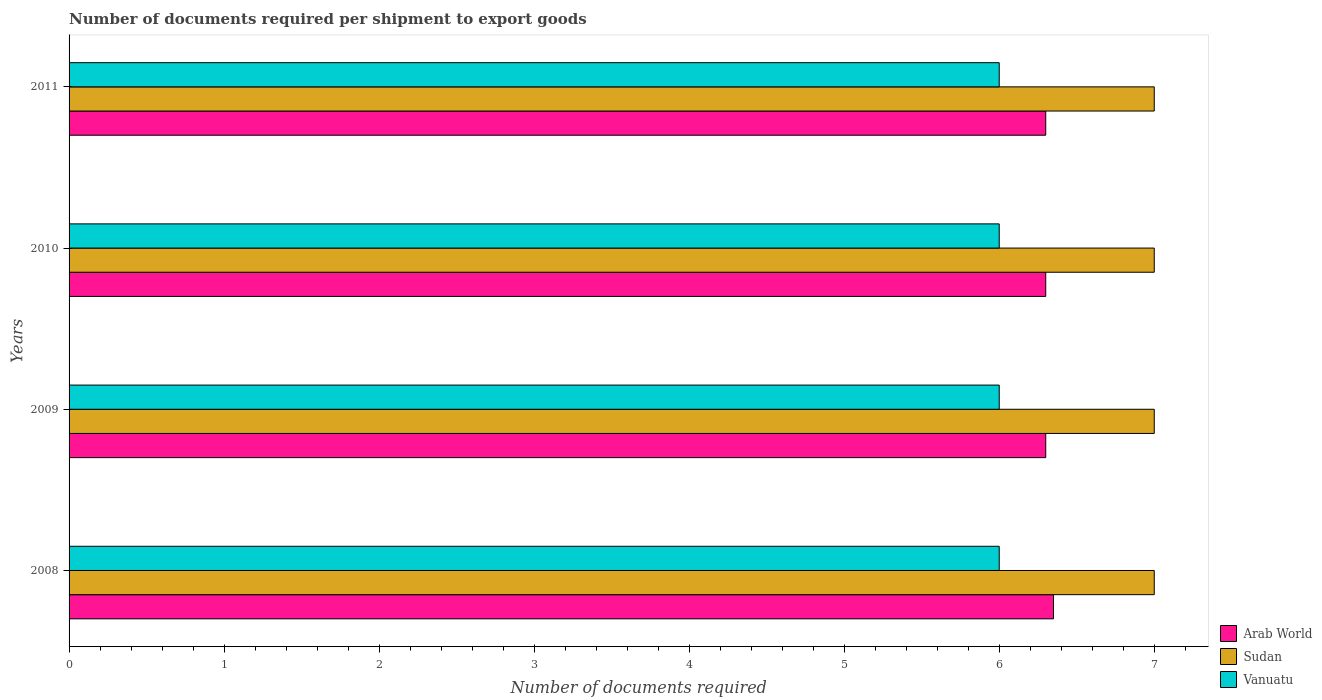How many bars are there on the 3rd tick from the bottom?
Offer a terse response. 3. What is the number of documents required per shipment to export goods in Arab World in 2011?
Ensure brevity in your answer.  6.3. Across all years, what is the maximum number of documents required per shipment to export goods in Sudan?
Offer a very short reply. 7. Across all years, what is the minimum number of documents required per shipment to export goods in Vanuatu?
Offer a very short reply. 6. In which year was the number of documents required per shipment to export goods in Vanuatu maximum?
Give a very brief answer. 2008. What is the total number of documents required per shipment to export goods in Arab World in the graph?
Provide a succinct answer. 25.25. What is the difference between the number of documents required per shipment to export goods in Vanuatu in 2008 and that in 2010?
Make the answer very short. 0. What is the difference between the number of documents required per shipment to export goods in Arab World in 2009 and the number of documents required per shipment to export goods in Vanuatu in 2011?
Give a very brief answer. 0.3. What is the average number of documents required per shipment to export goods in Arab World per year?
Make the answer very short. 6.31. In the year 2010, what is the difference between the number of documents required per shipment to export goods in Vanuatu and number of documents required per shipment to export goods in Sudan?
Provide a succinct answer. -1. What is the ratio of the number of documents required per shipment to export goods in Sudan in 2010 to that in 2011?
Offer a very short reply. 1. Is the difference between the number of documents required per shipment to export goods in Vanuatu in 2008 and 2009 greater than the difference between the number of documents required per shipment to export goods in Sudan in 2008 and 2009?
Provide a short and direct response. No. What is the difference between the highest and the second highest number of documents required per shipment to export goods in Vanuatu?
Your response must be concise. 0. What is the difference between the highest and the lowest number of documents required per shipment to export goods in Arab World?
Provide a short and direct response. 0.05. Is the sum of the number of documents required per shipment to export goods in Arab World in 2008 and 2011 greater than the maximum number of documents required per shipment to export goods in Vanuatu across all years?
Make the answer very short. Yes. What does the 3rd bar from the top in 2011 represents?
Offer a very short reply. Arab World. What does the 2nd bar from the bottom in 2010 represents?
Provide a succinct answer. Sudan. Is it the case that in every year, the sum of the number of documents required per shipment to export goods in Vanuatu and number of documents required per shipment to export goods in Sudan is greater than the number of documents required per shipment to export goods in Arab World?
Provide a short and direct response. Yes. How many bars are there?
Give a very brief answer. 12. Are all the bars in the graph horizontal?
Provide a short and direct response. Yes. What is the difference between two consecutive major ticks on the X-axis?
Offer a terse response. 1. Does the graph contain grids?
Give a very brief answer. No. What is the title of the graph?
Provide a short and direct response. Number of documents required per shipment to export goods. What is the label or title of the X-axis?
Offer a terse response. Number of documents required. What is the Number of documents required in Arab World in 2008?
Make the answer very short. 6.35. What is the Number of documents required in Sudan in 2008?
Ensure brevity in your answer.  7. What is the Number of documents required in Arab World in 2009?
Provide a succinct answer. 6.3. What is the Number of documents required in Sudan in 2009?
Offer a terse response. 7. What is the Number of documents required in Vanuatu in 2009?
Offer a terse response. 6. What is the Number of documents required of Arab World in 2010?
Provide a succinct answer. 6.3. Across all years, what is the maximum Number of documents required in Arab World?
Your answer should be very brief. 6.35. Across all years, what is the maximum Number of documents required of Vanuatu?
Keep it short and to the point. 6. Across all years, what is the minimum Number of documents required in Arab World?
Make the answer very short. 6.3. Across all years, what is the minimum Number of documents required in Sudan?
Provide a succinct answer. 7. What is the total Number of documents required in Arab World in the graph?
Make the answer very short. 25.25. What is the total Number of documents required of Sudan in the graph?
Ensure brevity in your answer.  28. What is the difference between the Number of documents required of Arab World in 2008 and that in 2009?
Your answer should be very brief. 0.05. What is the difference between the Number of documents required of Sudan in 2008 and that in 2009?
Offer a terse response. 0. What is the difference between the Number of documents required of Vanuatu in 2009 and that in 2010?
Offer a very short reply. 0. What is the difference between the Number of documents required of Arab World in 2009 and that in 2011?
Keep it short and to the point. 0. What is the difference between the Number of documents required in Sudan in 2009 and that in 2011?
Provide a short and direct response. 0. What is the difference between the Number of documents required in Vanuatu in 2009 and that in 2011?
Offer a very short reply. 0. What is the difference between the Number of documents required in Arab World in 2010 and that in 2011?
Ensure brevity in your answer.  0. What is the difference between the Number of documents required in Arab World in 2008 and the Number of documents required in Sudan in 2009?
Your answer should be compact. -0.65. What is the difference between the Number of documents required of Sudan in 2008 and the Number of documents required of Vanuatu in 2009?
Keep it short and to the point. 1. What is the difference between the Number of documents required of Arab World in 2008 and the Number of documents required of Sudan in 2010?
Offer a very short reply. -0.65. What is the difference between the Number of documents required in Arab World in 2008 and the Number of documents required in Sudan in 2011?
Your answer should be very brief. -0.65. What is the difference between the Number of documents required of Arab World in 2008 and the Number of documents required of Vanuatu in 2011?
Provide a short and direct response. 0.35. What is the difference between the Number of documents required in Sudan in 2008 and the Number of documents required in Vanuatu in 2011?
Ensure brevity in your answer.  1. What is the difference between the Number of documents required in Arab World in 2009 and the Number of documents required in Sudan in 2010?
Make the answer very short. -0.7. What is the difference between the Number of documents required of Arab World in 2009 and the Number of documents required of Vanuatu in 2010?
Your response must be concise. 0.3. What is the difference between the Number of documents required of Sudan in 2009 and the Number of documents required of Vanuatu in 2010?
Give a very brief answer. 1. What is the difference between the Number of documents required in Arab World in 2009 and the Number of documents required in Vanuatu in 2011?
Give a very brief answer. 0.3. What is the average Number of documents required of Arab World per year?
Your answer should be compact. 6.31. In the year 2008, what is the difference between the Number of documents required in Arab World and Number of documents required in Sudan?
Ensure brevity in your answer.  -0.65. In the year 2008, what is the difference between the Number of documents required of Arab World and Number of documents required of Vanuatu?
Your answer should be compact. 0.35. In the year 2011, what is the difference between the Number of documents required in Sudan and Number of documents required in Vanuatu?
Give a very brief answer. 1. What is the ratio of the Number of documents required of Arab World in 2008 to that in 2009?
Provide a short and direct response. 1.01. What is the ratio of the Number of documents required in Sudan in 2008 to that in 2009?
Your answer should be compact. 1. What is the ratio of the Number of documents required in Vanuatu in 2008 to that in 2009?
Provide a succinct answer. 1. What is the ratio of the Number of documents required in Arab World in 2008 to that in 2010?
Make the answer very short. 1.01. What is the ratio of the Number of documents required in Sudan in 2008 to that in 2010?
Provide a short and direct response. 1. What is the ratio of the Number of documents required of Arab World in 2008 to that in 2011?
Give a very brief answer. 1.01. What is the ratio of the Number of documents required of Vanuatu in 2008 to that in 2011?
Your response must be concise. 1. What is the ratio of the Number of documents required of Arab World in 2009 to that in 2011?
Give a very brief answer. 1. What is the ratio of the Number of documents required in Arab World in 2010 to that in 2011?
Make the answer very short. 1. 